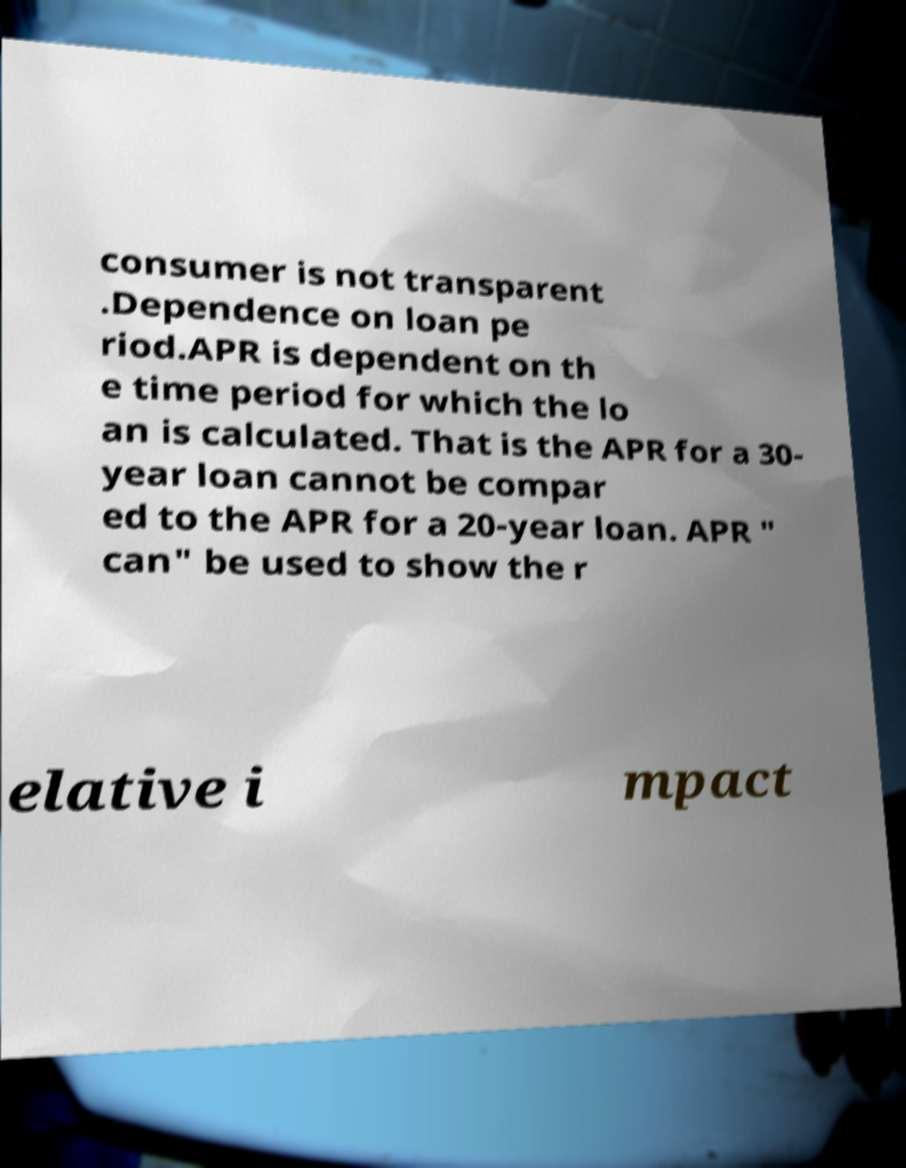I need the written content from this picture converted into text. Can you do that? consumer is not transparent .Dependence on loan pe riod.APR is dependent on th e time period for which the lo an is calculated. That is the APR for a 30- year loan cannot be compar ed to the APR for a 20-year loan. APR " can" be used to show the r elative i mpact 